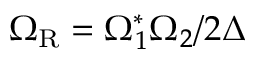<formula> <loc_0><loc_0><loc_500><loc_500>\Omega _ { R } = \Omega _ { 1 } ^ { * } \Omega _ { 2 } / 2 \Delta</formula> 